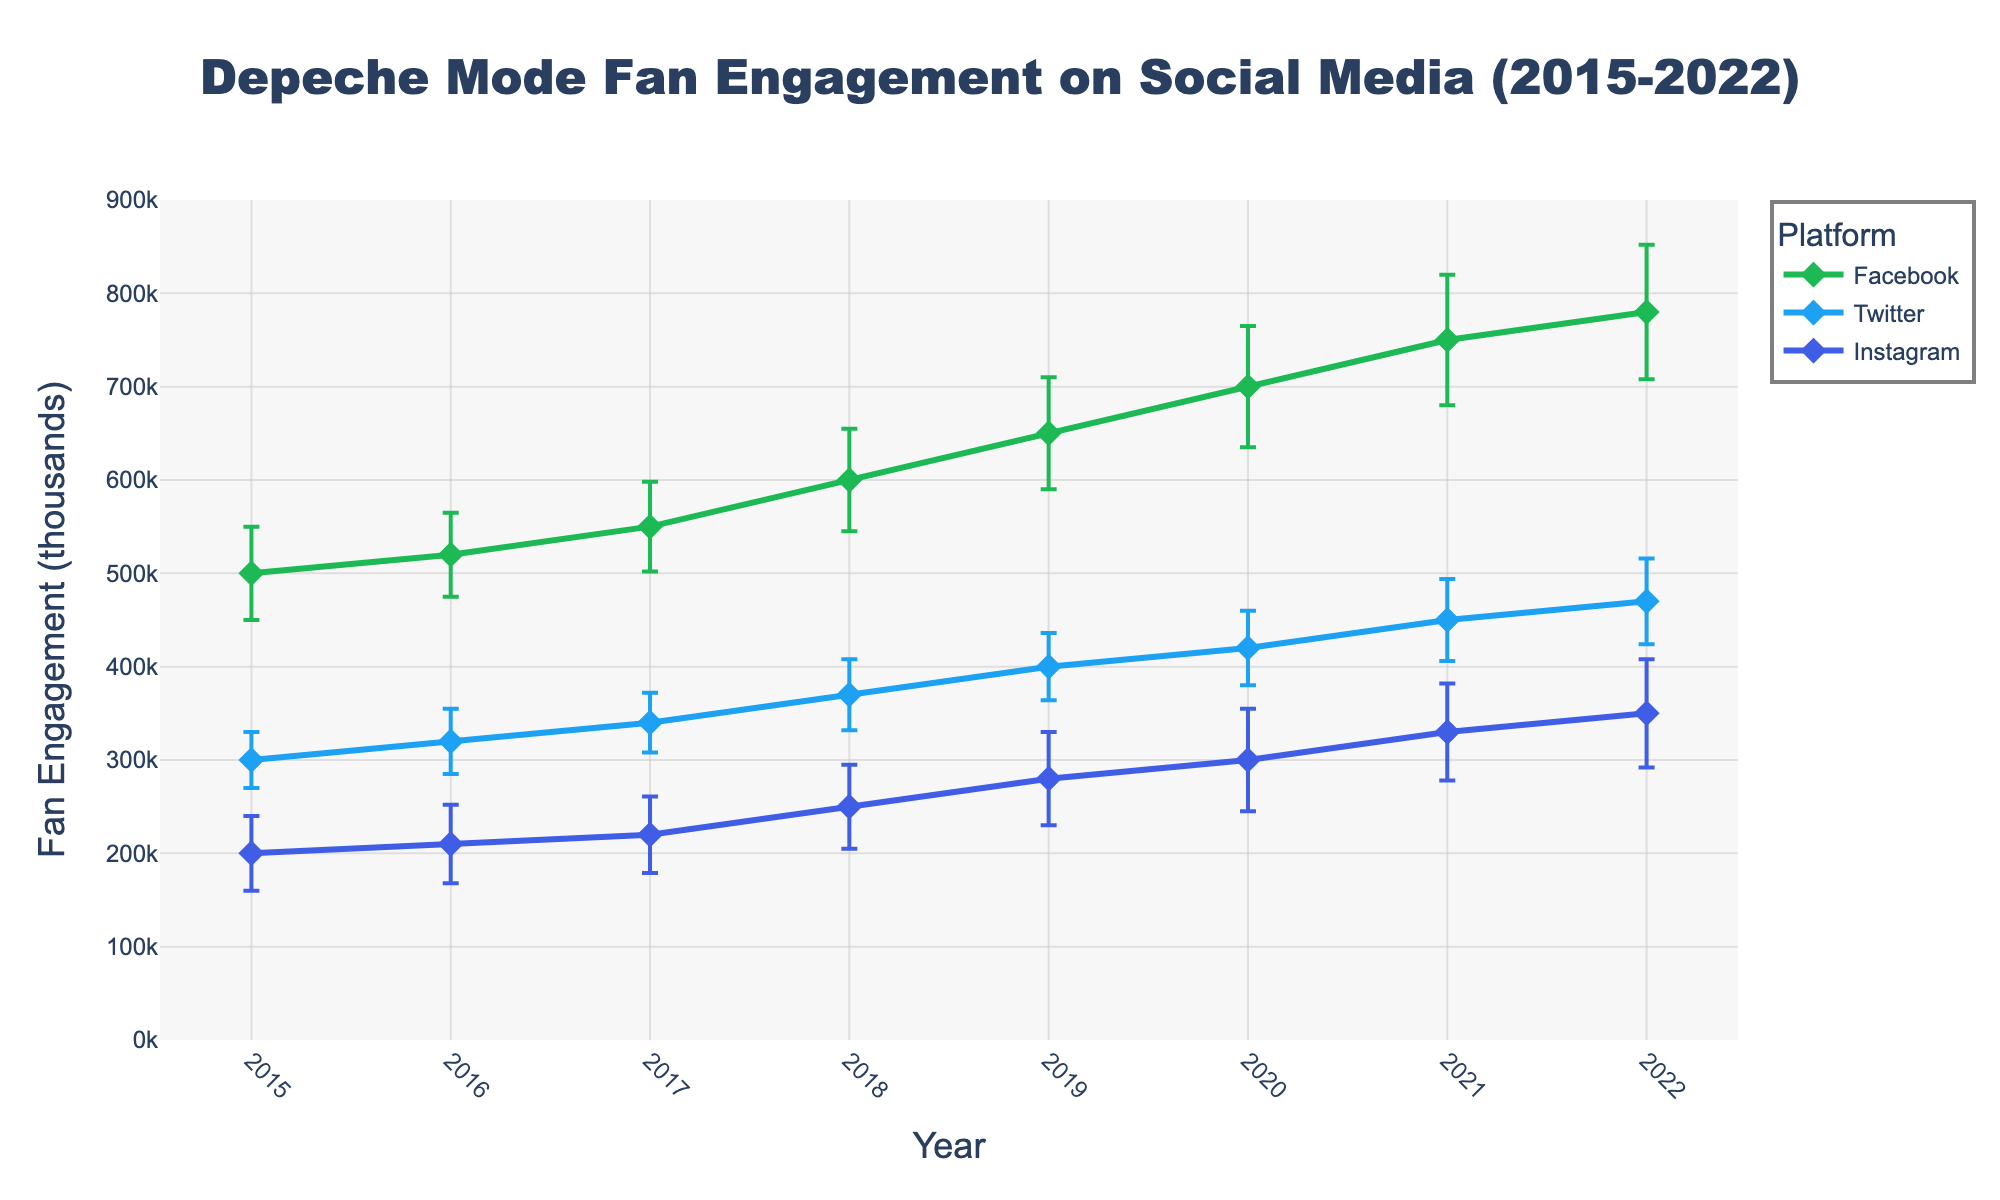What is the title of the plot? The title is clearly displayed at the top center of the plot.
Answer: Depeche Mode Fan Engagement on Social Media (2015-2022) How many platforms are displayed in the plot? By observing the legend, which lists each platform, we can see there are three platforms: Facebook, Twitter, and Instagram.
Answer: Three What was the mean fan engagement on Facebook in 2019? Locate the year 2019 on the x-axis, then follow it upwards to the Facebook line and read the point’s y-value.
Answer: 650k Which platform had the highest fan engagement mean in 2022? Identify the year 2022 on the x-axis, then compare the highest y-value among all platforms at this point.
Answer: Facebook Between 2018 and 2019, which platform showed the largest increase in mean engagement? Compare the differences in mean engagement from 2018 to 2019 for all platforms by observing the slopes of the lines.
Answer: Facebook What is the trend of Twitter fan engagement from 2015 to 2022? Follow the Twitter line from 2015 to 2022, noticing its general direction (upward or downward).
Answer: Increasing What is the standard deviation range for Instagram fan engagement in 2020? In 2020, look at the Instagram point and note the error bars around it representing the standard deviation. The range is Mean ± StdDev.
Answer: 245k to 355k What period saw the steepest increase in Facebook fan engagement? Examine the slope of the Facebook line across the years and identify the segment with the steepest slope.
Answer: 2019 to 2020 How does the fan engagement mean in 2022 compare between Facebook and Instagram? On the x-axis for the year 2022, compare the y-values of Facebook and Instagram.
Answer: Facebook is higher 